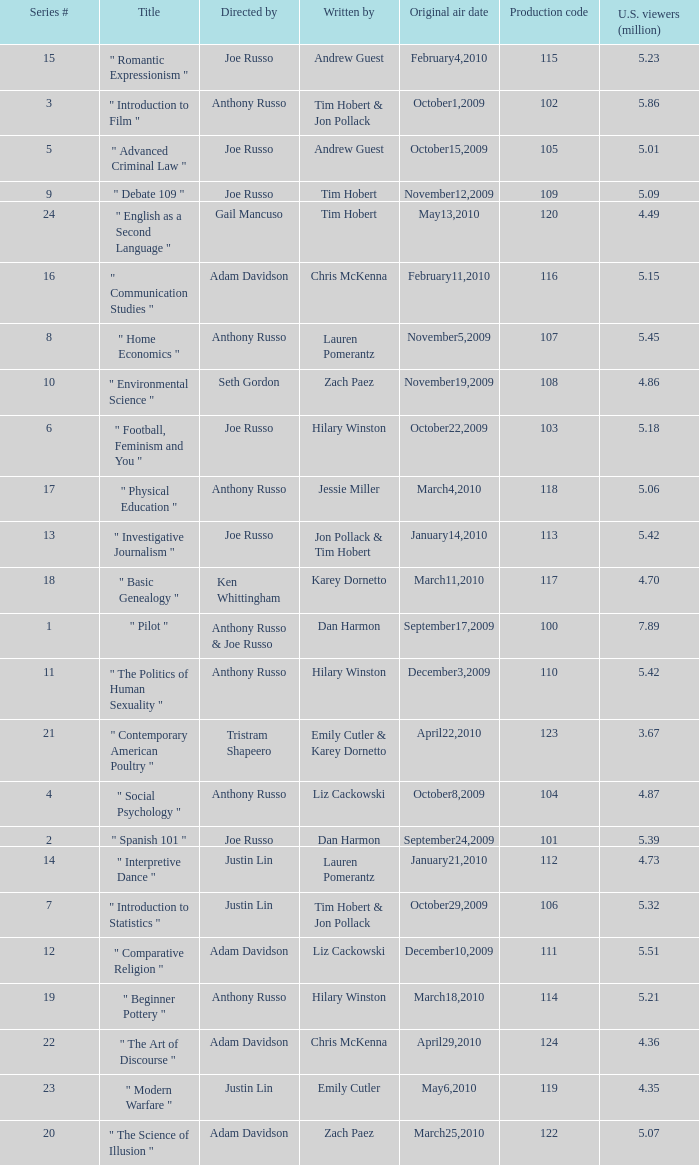Write the full table. {'header': ['Series #', 'Title', 'Directed by', 'Written by', 'Original air date', 'Production code', 'U.S. viewers (million)'], 'rows': [['15', '" Romantic Expressionism "', 'Joe Russo', 'Andrew Guest', 'February4,2010', '115', '5.23'], ['3', '" Introduction to Film "', 'Anthony Russo', 'Tim Hobert & Jon Pollack', 'October1,2009', '102', '5.86'], ['5', '" Advanced Criminal Law "', 'Joe Russo', 'Andrew Guest', 'October15,2009', '105', '5.01'], ['9', '" Debate 109 "', 'Joe Russo', 'Tim Hobert', 'November12,2009', '109', '5.09'], ['24', '" English as a Second Language "', 'Gail Mancuso', 'Tim Hobert', 'May13,2010', '120', '4.49'], ['16', '" Communication Studies "', 'Adam Davidson', 'Chris McKenna', 'February11,2010', '116', '5.15'], ['8', '" Home Economics "', 'Anthony Russo', 'Lauren Pomerantz', 'November5,2009', '107', '5.45'], ['10', '" Environmental Science "', 'Seth Gordon', 'Zach Paez', 'November19,2009', '108', '4.86'], ['6', '" Football, Feminism and You "', 'Joe Russo', 'Hilary Winston', 'October22,2009', '103', '5.18'], ['17', '" Physical Education "', 'Anthony Russo', 'Jessie Miller', 'March4,2010', '118', '5.06'], ['13', '" Investigative Journalism "', 'Joe Russo', 'Jon Pollack & Tim Hobert', 'January14,2010', '113', '5.42'], ['18', '" Basic Genealogy "', 'Ken Whittingham', 'Karey Dornetto', 'March11,2010', '117', '4.70'], ['1', '" Pilot "', 'Anthony Russo & Joe Russo', 'Dan Harmon', 'September17,2009', '100', '7.89'], ['11', '" The Politics of Human Sexuality "', 'Anthony Russo', 'Hilary Winston', 'December3,2009', '110', '5.42'], ['21', '" Contemporary American Poultry "', 'Tristram Shapeero', 'Emily Cutler & Karey Dornetto', 'April22,2010', '123', '3.67'], ['4', '" Social Psychology "', 'Anthony Russo', 'Liz Cackowski', 'October8,2009', '104', '4.87'], ['2', '" Spanish 101 "', 'Joe Russo', 'Dan Harmon', 'September24,2009', '101', '5.39'], ['14', '" Interpretive Dance "', 'Justin Lin', 'Lauren Pomerantz', 'January21,2010', '112', '4.73'], ['7', '" Introduction to Statistics "', 'Justin Lin', 'Tim Hobert & Jon Pollack', 'October29,2009', '106', '5.32'], ['12', '" Comparative Religion "', 'Adam Davidson', 'Liz Cackowski', 'December10,2009', '111', '5.51'], ['19', '" Beginner Pottery "', 'Anthony Russo', 'Hilary Winston', 'March18,2010', '114', '5.21'], ['22', '" The Art of Discourse "', 'Adam Davidson', 'Chris McKenna', 'April29,2010', '124', '4.36'], ['23', '" Modern Warfare "', 'Justin Lin', 'Emily Cutler', 'May6,2010', '119', '4.35'], ['20', '" The Science of Illusion "', 'Adam Davidson', 'Zach Paez', 'March25,2010', '122', '5.07']]} What is the title of the series # 8? " Home Economics ". 